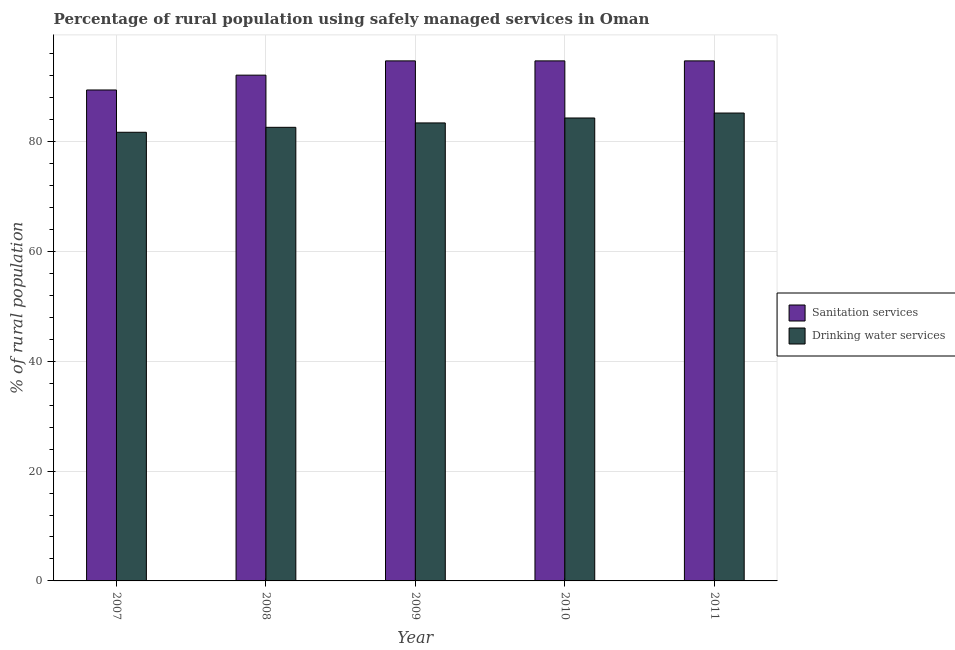How many different coloured bars are there?
Offer a very short reply. 2. How many bars are there on the 3rd tick from the left?
Your answer should be compact. 2. How many bars are there on the 3rd tick from the right?
Ensure brevity in your answer.  2. In how many cases, is the number of bars for a given year not equal to the number of legend labels?
Keep it short and to the point. 0. What is the percentage of rural population who used drinking water services in 2007?
Your response must be concise. 81.7. Across all years, what is the maximum percentage of rural population who used sanitation services?
Make the answer very short. 94.7. Across all years, what is the minimum percentage of rural population who used drinking water services?
Your response must be concise. 81.7. In which year was the percentage of rural population who used sanitation services maximum?
Your response must be concise. 2009. In which year was the percentage of rural population who used sanitation services minimum?
Provide a short and direct response. 2007. What is the total percentage of rural population who used sanitation services in the graph?
Offer a terse response. 465.6. What is the difference between the percentage of rural population who used sanitation services in 2009 and that in 2011?
Give a very brief answer. 0. What is the difference between the percentage of rural population who used sanitation services in 2011 and the percentage of rural population who used drinking water services in 2009?
Your answer should be very brief. 0. What is the average percentage of rural population who used sanitation services per year?
Offer a terse response. 93.12. In the year 2010, what is the difference between the percentage of rural population who used sanitation services and percentage of rural population who used drinking water services?
Your response must be concise. 0. What is the ratio of the percentage of rural population who used drinking water services in 2008 to that in 2011?
Your answer should be compact. 0.97. Is the percentage of rural population who used sanitation services in 2008 less than that in 2009?
Offer a terse response. Yes. Is the difference between the percentage of rural population who used drinking water services in 2009 and 2011 greater than the difference between the percentage of rural population who used sanitation services in 2009 and 2011?
Ensure brevity in your answer.  No. What is the difference between the highest and the second highest percentage of rural population who used drinking water services?
Make the answer very short. 0.9. What is the difference between the highest and the lowest percentage of rural population who used sanitation services?
Provide a succinct answer. 5.3. In how many years, is the percentage of rural population who used drinking water services greater than the average percentage of rural population who used drinking water services taken over all years?
Make the answer very short. 2. Is the sum of the percentage of rural population who used drinking water services in 2007 and 2011 greater than the maximum percentage of rural population who used sanitation services across all years?
Keep it short and to the point. Yes. What does the 1st bar from the left in 2010 represents?
Keep it short and to the point. Sanitation services. What does the 2nd bar from the right in 2007 represents?
Ensure brevity in your answer.  Sanitation services. Are the values on the major ticks of Y-axis written in scientific E-notation?
Your answer should be very brief. No. Where does the legend appear in the graph?
Give a very brief answer. Center right. How many legend labels are there?
Your response must be concise. 2. How are the legend labels stacked?
Ensure brevity in your answer.  Vertical. What is the title of the graph?
Provide a short and direct response. Percentage of rural population using safely managed services in Oman. What is the label or title of the Y-axis?
Provide a succinct answer. % of rural population. What is the % of rural population of Sanitation services in 2007?
Provide a succinct answer. 89.4. What is the % of rural population of Drinking water services in 2007?
Your answer should be very brief. 81.7. What is the % of rural population in Sanitation services in 2008?
Offer a very short reply. 92.1. What is the % of rural population of Drinking water services in 2008?
Ensure brevity in your answer.  82.6. What is the % of rural population of Sanitation services in 2009?
Ensure brevity in your answer.  94.7. What is the % of rural population of Drinking water services in 2009?
Ensure brevity in your answer.  83.4. What is the % of rural population of Sanitation services in 2010?
Your response must be concise. 94.7. What is the % of rural population in Drinking water services in 2010?
Make the answer very short. 84.3. What is the % of rural population of Sanitation services in 2011?
Your answer should be compact. 94.7. What is the % of rural population of Drinking water services in 2011?
Keep it short and to the point. 85.2. Across all years, what is the maximum % of rural population in Sanitation services?
Offer a terse response. 94.7. Across all years, what is the maximum % of rural population in Drinking water services?
Your answer should be compact. 85.2. Across all years, what is the minimum % of rural population in Sanitation services?
Make the answer very short. 89.4. Across all years, what is the minimum % of rural population of Drinking water services?
Ensure brevity in your answer.  81.7. What is the total % of rural population of Sanitation services in the graph?
Give a very brief answer. 465.6. What is the total % of rural population in Drinking water services in the graph?
Offer a very short reply. 417.2. What is the difference between the % of rural population in Sanitation services in 2007 and that in 2008?
Provide a succinct answer. -2.7. What is the difference between the % of rural population of Drinking water services in 2007 and that in 2009?
Provide a short and direct response. -1.7. What is the difference between the % of rural population in Sanitation services in 2007 and that in 2010?
Ensure brevity in your answer.  -5.3. What is the difference between the % of rural population in Sanitation services in 2007 and that in 2011?
Keep it short and to the point. -5.3. What is the difference between the % of rural population of Drinking water services in 2007 and that in 2011?
Your answer should be very brief. -3.5. What is the difference between the % of rural population of Sanitation services in 2008 and that in 2009?
Offer a terse response. -2.6. What is the difference between the % of rural population of Drinking water services in 2008 and that in 2010?
Keep it short and to the point. -1.7. What is the difference between the % of rural population of Sanitation services in 2009 and that in 2010?
Offer a very short reply. 0. What is the difference between the % of rural population of Drinking water services in 2009 and that in 2010?
Your response must be concise. -0.9. What is the difference between the % of rural population of Sanitation services in 2009 and that in 2011?
Provide a succinct answer. 0. What is the difference between the % of rural population in Sanitation services in 2010 and that in 2011?
Give a very brief answer. 0. What is the difference between the % of rural population of Drinking water services in 2010 and that in 2011?
Provide a succinct answer. -0.9. What is the difference between the % of rural population in Sanitation services in 2007 and the % of rural population in Drinking water services in 2008?
Offer a very short reply. 6.8. What is the difference between the % of rural population of Sanitation services in 2008 and the % of rural population of Drinking water services in 2009?
Provide a succinct answer. 8.7. What is the difference between the % of rural population in Sanitation services in 2009 and the % of rural population in Drinking water services in 2010?
Your answer should be compact. 10.4. What is the difference between the % of rural population in Sanitation services in 2009 and the % of rural population in Drinking water services in 2011?
Offer a terse response. 9.5. What is the average % of rural population in Sanitation services per year?
Ensure brevity in your answer.  93.12. What is the average % of rural population of Drinking water services per year?
Ensure brevity in your answer.  83.44. What is the ratio of the % of rural population in Sanitation services in 2007 to that in 2008?
Provide a short and direct response. 0.97. What is the ratio of the % of rural population of Sanitation services in 2007 to that in 2009?
Ensure brevity in your answer.  0.94. What is the ratio of the % of rural population in Drinking water services in 2007 to that in 2009?
Your answer should be very brief. 0.98. What is the ratio of the % of rural population in Sanitation services in 2007 to that in 2010?
Offer a terse response. 0.94. What is the ratio of the % of rural population in Drinking water services in 2007 to that in 2010?
Your answer should be compact. 0.97. What is the ratio of the % of rural population of Sanitation services in 2007 to that in 2011?
Make the answer very short. 0.94. What is the ratio of the % of rural population in Drinking water services in 2007 to that in 2011?
Give a very brief answer. 0.96. What is the ratio of the % of rural population of Sanitation services in 2008 to that in 2009?
Your response must be concise. 0.97. What is the ratio of the % of rural population of Sanitation services in 2008 to that in 2010?
Ensure brevity in your answer.  0.97. What is the ratio of the % of rural population in Drinking water services in 2008 to that in 2010?
Provide a succinct answer. 0.98. What is the ratio of the % of rural population in Sanitation services in 2008 to that in 2011?
Offer a terse response. 0.97. What is the ratio of the % of rural population of Drinking water services in 2008 to that in 2011?
Your answer should be compact. 0.97. What is the ratio of the % of rural population of Drinking water services in 2009 to that in 2010?
Provide a succinct answer. 0.99. What is the ratio of the % of rural population of Drinking water services in 2009 to that in 2011?
Your response must be concise. 0.98. What is the ratio of the % of rural population in Drinking water services in 2010 to that in 2011?
Offer a terse response. 0.99. What is the difference between the highest and the second highest % of rural population of Sanitation services?
Give a very brief answer. 0. What is the difference between the highest and the lowest % of rural population in Drinking water services?
Your answer should be compact. 3.5. 